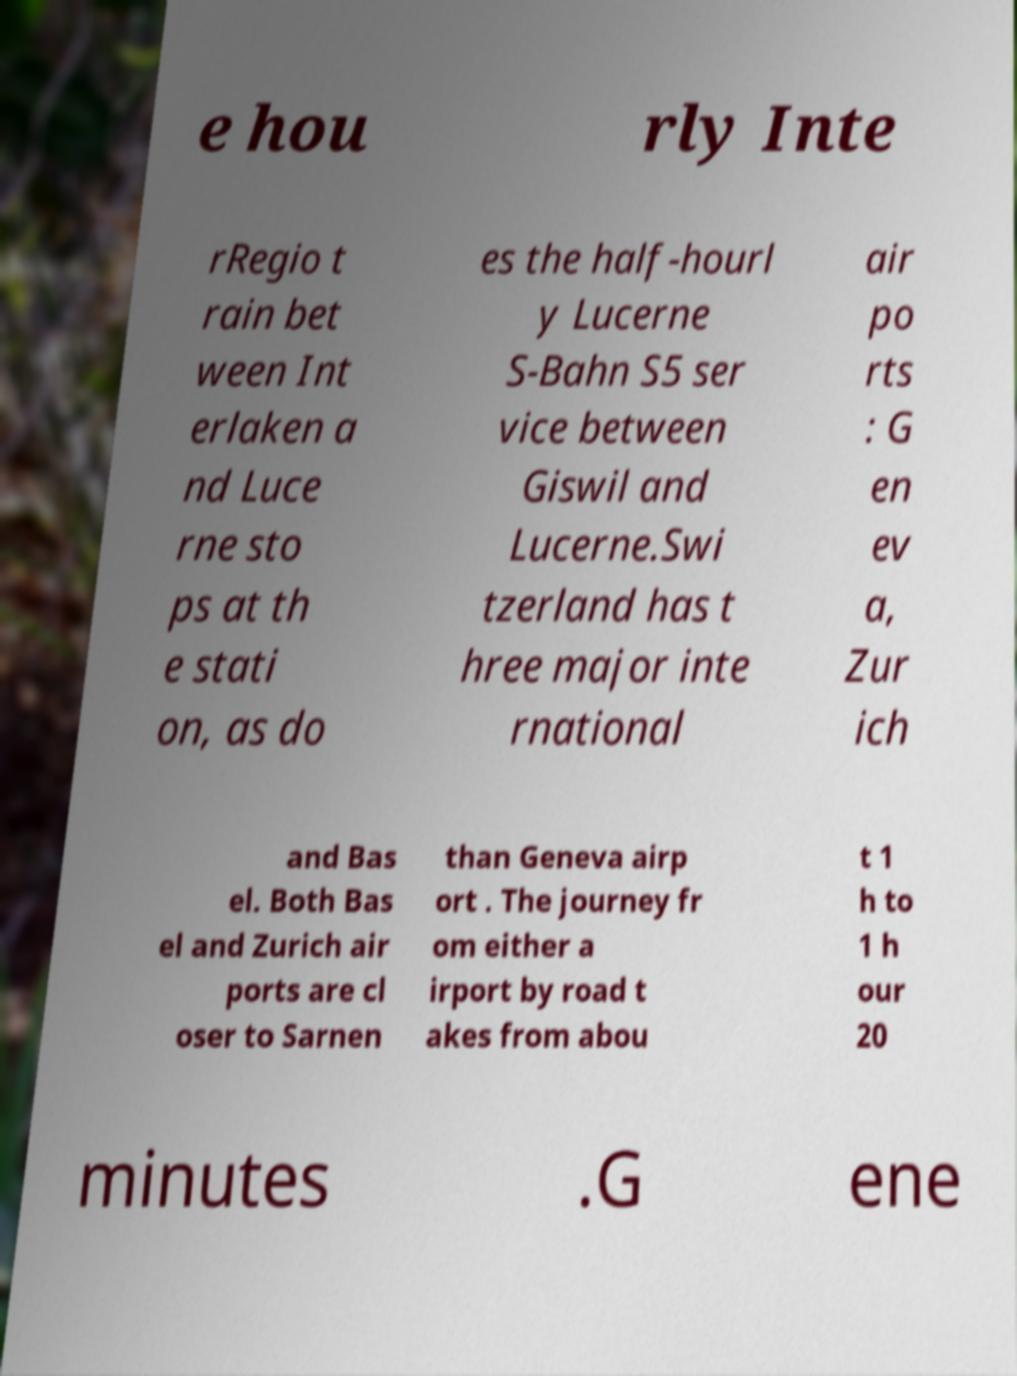For documentation purposes, I need the text within this image transcribed. Could you provide that? e hou rly Inte rRegio t rain bet ween Int erlaken a nd Luce rne sto ps at th e stati on, as do es the half-hourl y Lucerne S-Bahn S5 ser vice between Giswil and Lucerne.Swi tzerland has t hree major inte rnational air po rts : G en ev a, Zur ich and Bas el. Both Bas el and Zurich air ports are cl oser to Sarnen than Geneva airp ort . The journey fr om either a irport by road t akes from abou t 1 h to 1 h our 20 minutes .G ene 